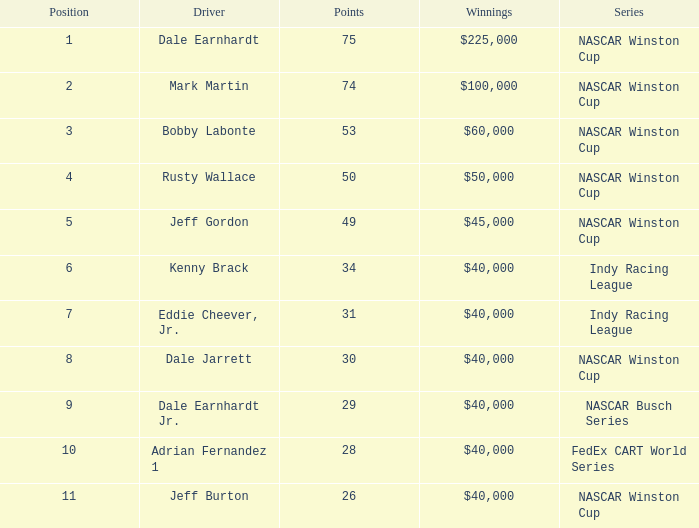Would you mind parsing the complete table? {'header': ['Position', 'Driver', 'Points', 'Winnings', 'Series'], 'rows': [['1', 'Dale Earnhardt', '75', '$225,000', 'NASCAR Winston Cup'], ['2', 'Mark Martin', '74', '$100,000', 'NASCAR Winston Cup'], ['3', 'Bobby Labonte', '53', '$60,000', 'NASCAR Winston Cup'], ['4', 'Rusty Wallace', '50', '$50,000', 'NASCAR Winston Cup'], ['5', 'Jeff Gordon', '49', '$45,000', 'NASCAR Winston Cup'], ['6', 'Kenny Brack', '34', '$40,000', 'Indy Racing League'], ['7', 'Eddie Cheever, Jr.', '31', '$40,000', 'Indy Racing League'], ['8', 'Dale Jarrett', '30', '$40,000', 'NASCAR Winston Cup'], ['9', 'Dale Earnhardt Jr.', '29', '$40,000', 'NASCAR Busch Series'], ['10', 'Adrian Fernandez 1', '28', '$40,000', 'FedEx CART World Series'], ['11', 'Jeff Burton', '26', '$40,000', 'NASCAR Winston Cup']]} What position did the driver earn 31 points? 7.0. 